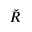Convert formula to latex. <formula><loc_0><loc_0><loc_500><loc_500>\breve { R }</formula> 